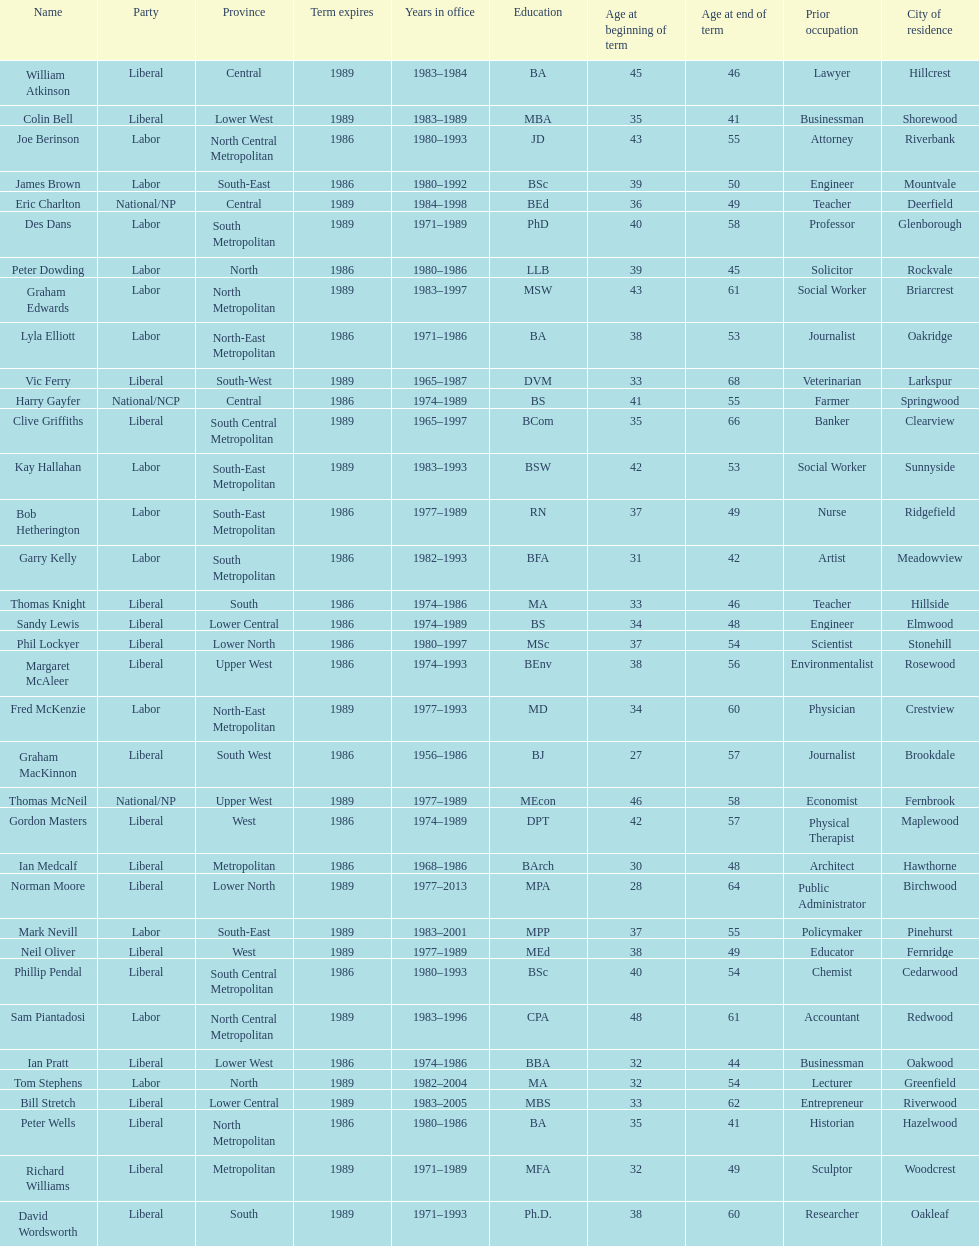What is the total number of members whose term expires in 1989? 9. 